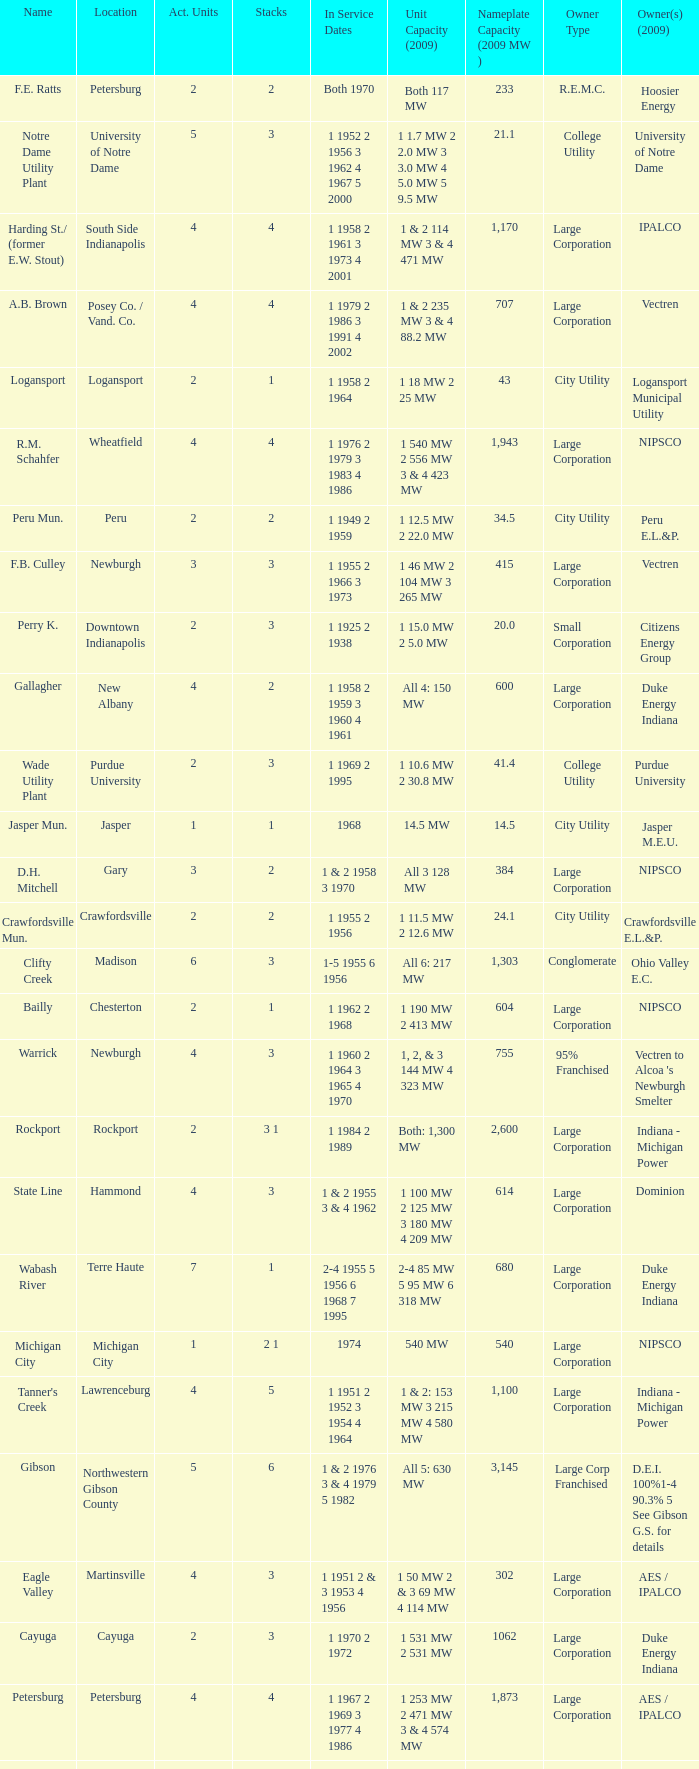Name the stacks for 1 1969 2 1995 3.0. 